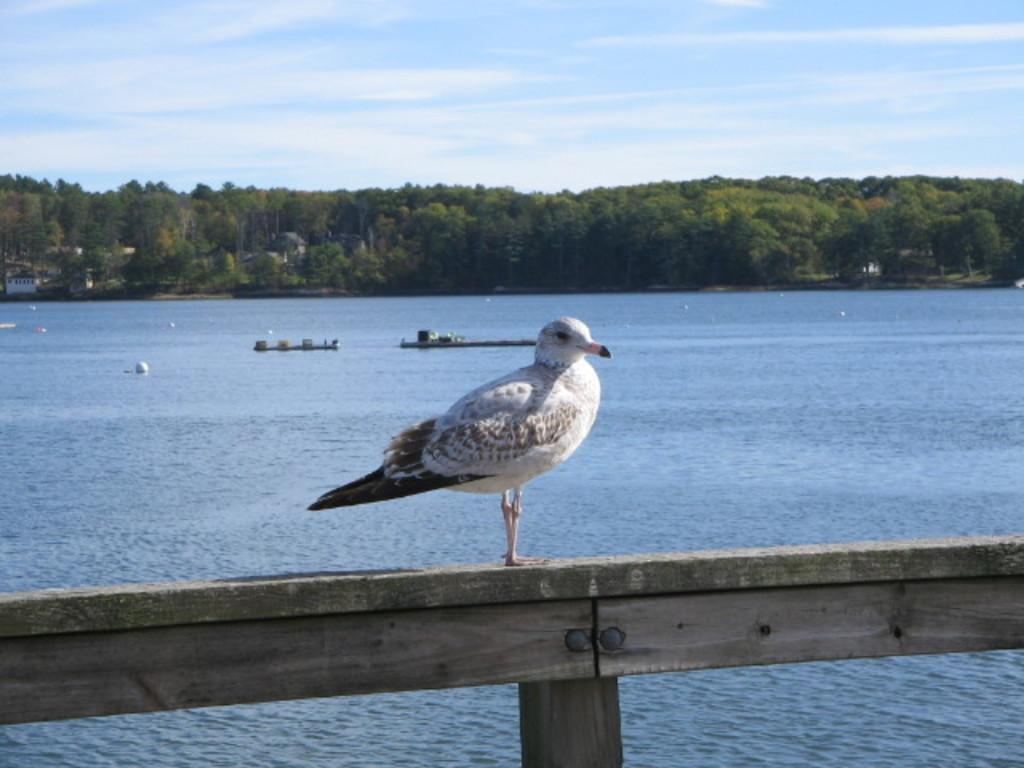What type of vegetation can be seen in the image? There are trees in the image. How would you describe the sky in the image? The sky is blue and cloudy. What animal is present in the image? There is a bird in the image. What colors can be seen on the bird? The bird is white and brown in color. Where is the bird located in the image? The bird is on a piece of wood. What type of bean is growing on the bird in the image? There are no beans present in the image, and the bird is not associated with any bean growth. In what year was the bird in the image born? The image does not provide any information about the bird's age or birth year. 